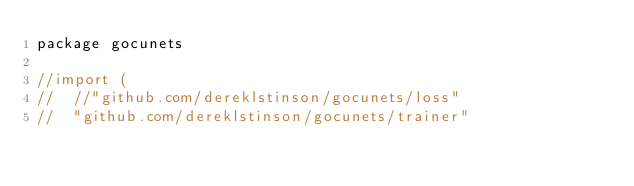<code> <loc_0><loc_0><loc_500><loc_500><_Go_>package gocunets

//import (
//	//"github.com/dereklstinson/gocunets/loss"
//	"github.com/dereklstinson/gocunets/trainer"</code> 